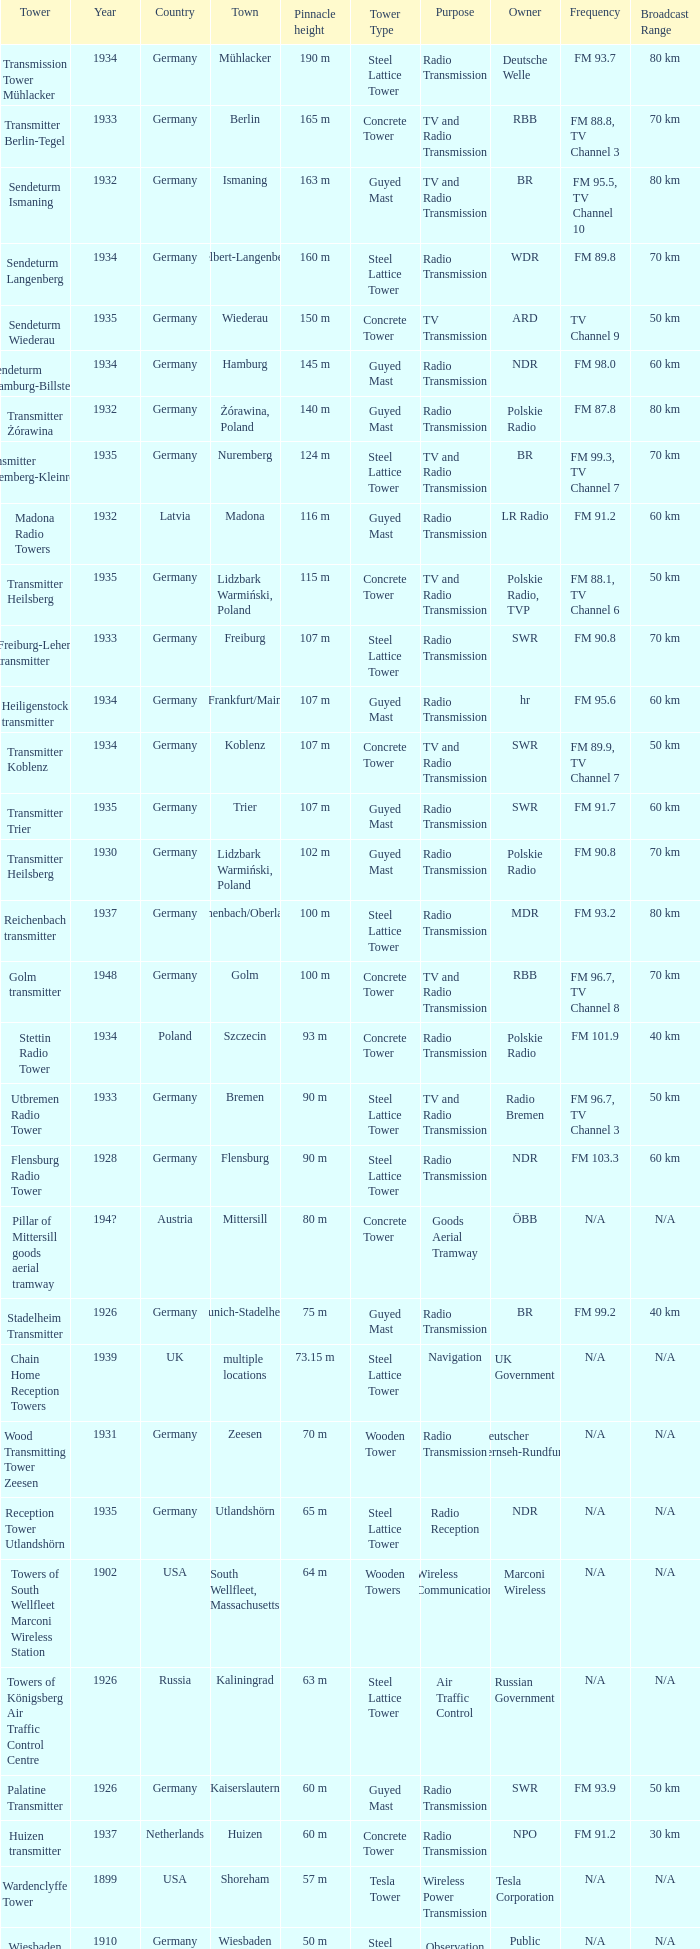Which country had a tower destroyed in 1899? USA. 